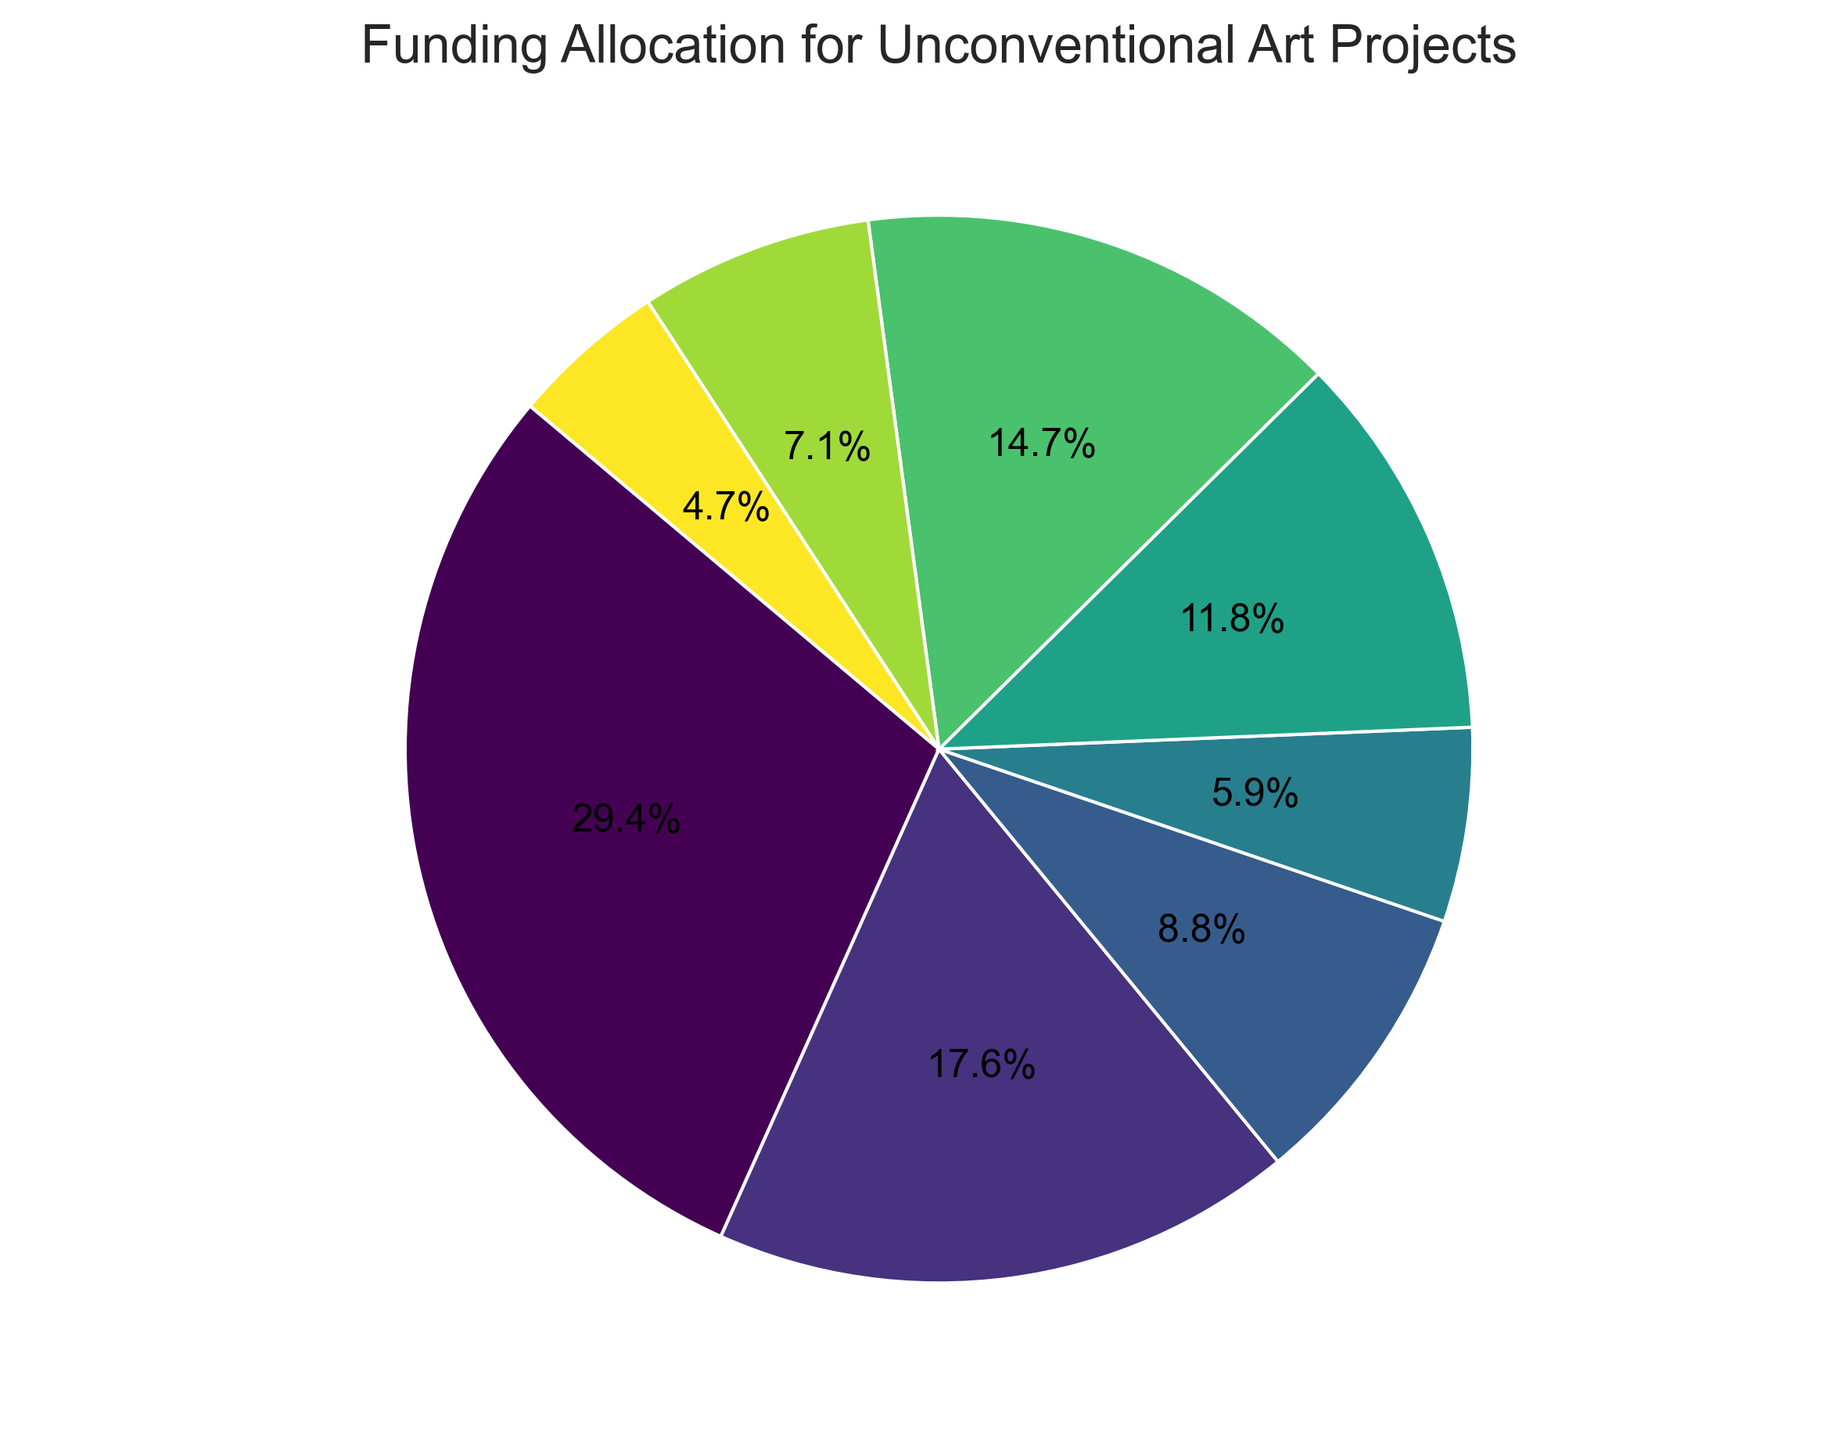What is the largest funding source for unconventional art projects? Look at the pie chart and identify the segment with the highest percentage, which represents the dominant funding source.
Answer: Government Grants What is the combined total percentage of Crowdfunding and Self-Funding? Find the segments labeled Crowdfunding and Self-Funding, then add their percentages (15.0% for Crowdfunding and 10.0% for Self-Funding).
Answer: 25.0% How does the proportion of Private Donations compare to Government Grants? Compare the sizes of the segments for Private Donations and Government Grants by looking at their percentages (30.0% vs. 50.0%).
Answer: Government Grants are higher Which funding source contributes exactly 8.0% of the total? Look for the segment labeled with 8.0% and identify its corresponding funding source (Local Business Partners).
Answer: Local Business Partners What is the total funding amount (in USD) represented by the chart? Sum all the funding amounts (50000 + 30000 + 15000 + 10000 + 20000 + 25000 + 12000 + 8000).
Answer: 170,000 USD Which two funding sources have the smallest contributions, and what are their percentages? Identify the two smallest segments by their percentages (Local Business Partners at 8.0% and Art Patron Contributions at 12.0%).
Answer: Local Business Partners at 8.0% and Art Patron Contributions at 12.0% Is the percentage of Foundation Grants greater than the percentage of Corporate Sponsorships? Find the percentages for Foundation Grants (20.0%) and Corporate Sponsorships (25.0%) and compare them.
Answer: No What is the visual representation color of Crowdfunding in the pie chart? Look at the segment labeled Crowdfunding and identify its color.
Answer: Green (or a spectrum related to it) What is the difference in percentage between the largest and the smallest funding sources? Determine the percentage of the largest source (50.0% for Government Grants) and the smallest (8.0% for Local Business Partners) and calculate the difference (50.0% - 8.0%).
Answer: 42.0% What is the average percentage share of Government Grants, Private Donations, and Crowdfunding? Add the percentages for Government Grants (50.0%), Private Donations (30.0%), and Crowdfunding (15.0%), then divide by 3 ((50.0 + 30.0 + 15.0) / 3).
Answer: 31.7% 